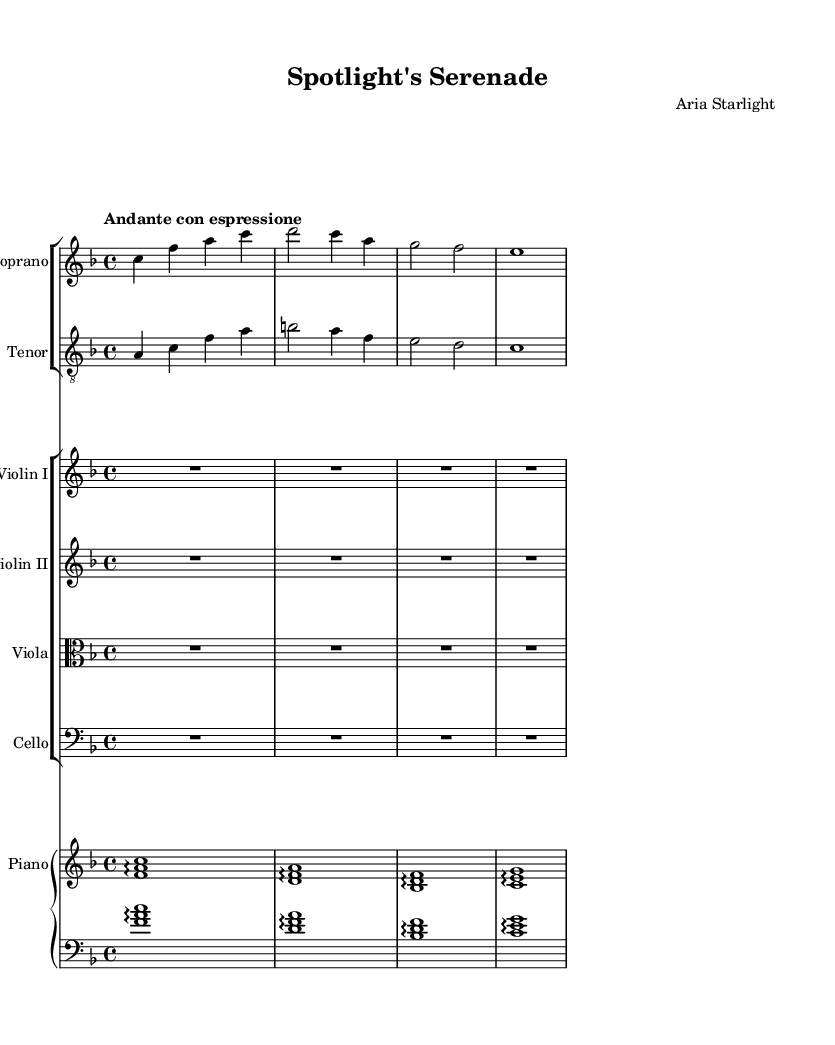What is the key signature of this music? The key signature is indicated at the beginning of the score and shows one flat, which indicates the piece is in F major.
Answer: F major What is the time signature of the music? The time signature, located at the beginning of the score, shows four beats per measure, which is indicated by the 4/4 notation.
Answer: 4/4 What is the tempo marking of this piece? The tempo marking found at the top of the score indicates "Andante con espressione," which suggests a moderate pace with expression.
Answer: Andante con espressione How many measures are in the soprano part? By counting the individual measures in the soprano staff, there are a total of four measures provided in the score.
Answer: Four What is the role of the cello in this piece? The cello part is written with no notes, indicating it provides a sustained background or can be omitted in this performance context.
Answer: Sustained background What is the relationship between the lyrics of the soprano and tenor parts? The soprano lyrics mention "Lights, camera, action," while the tenor lyrics refer to "Behind the scenes," indicating they express a shared theme of love in the entertainment industry but from different perspectives.
Answer: Shared theme of love What instruments accompany the main vocal parts in this opera? The accompaniment comes from a string section including two violins, a viola, and a cello, along with a piano.
Answer: Violins, viola, cello, piano 